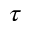Convert formula to latex. <formula><loc_0><loc_0><loc_500><loc_500>\tau</formula> 